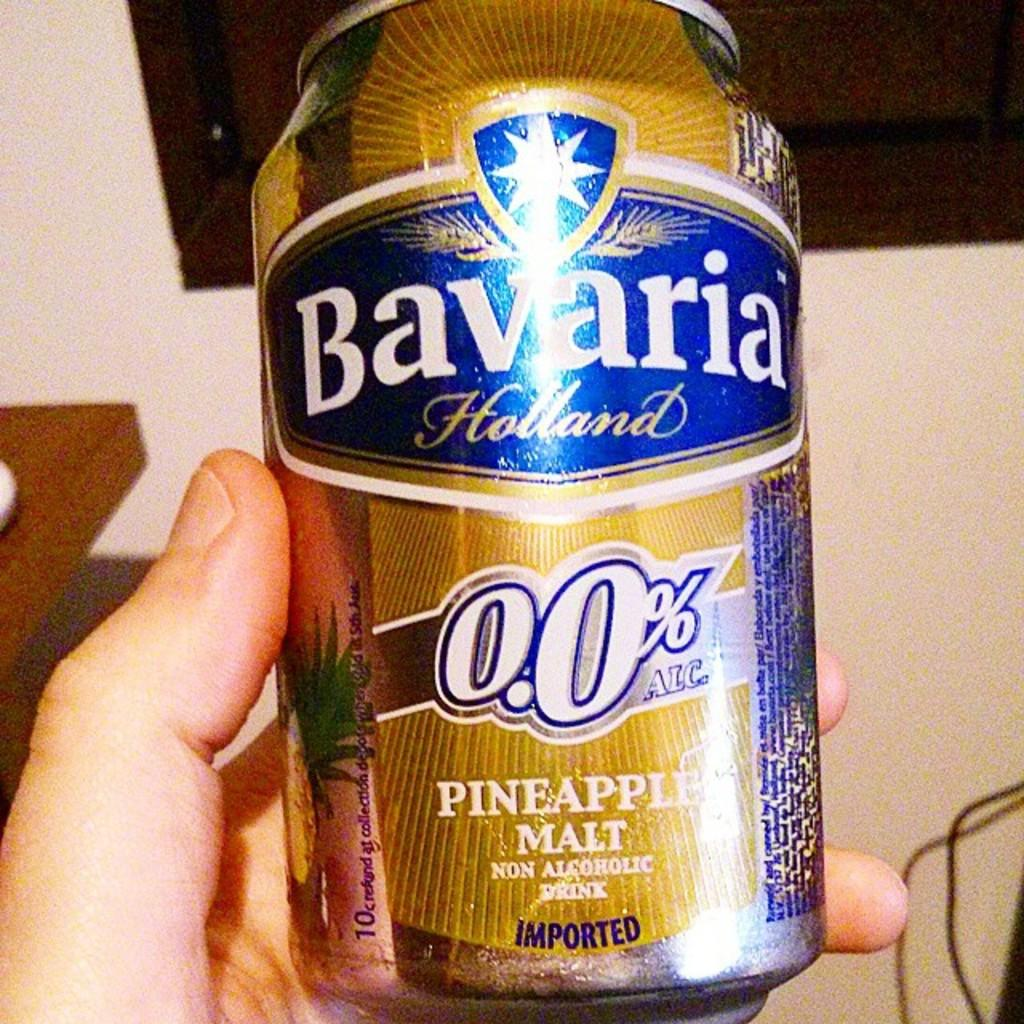<image>
Share a concise interpretation of the image provided. a can of Bavaria Holland Pineapple Malt in a hand 